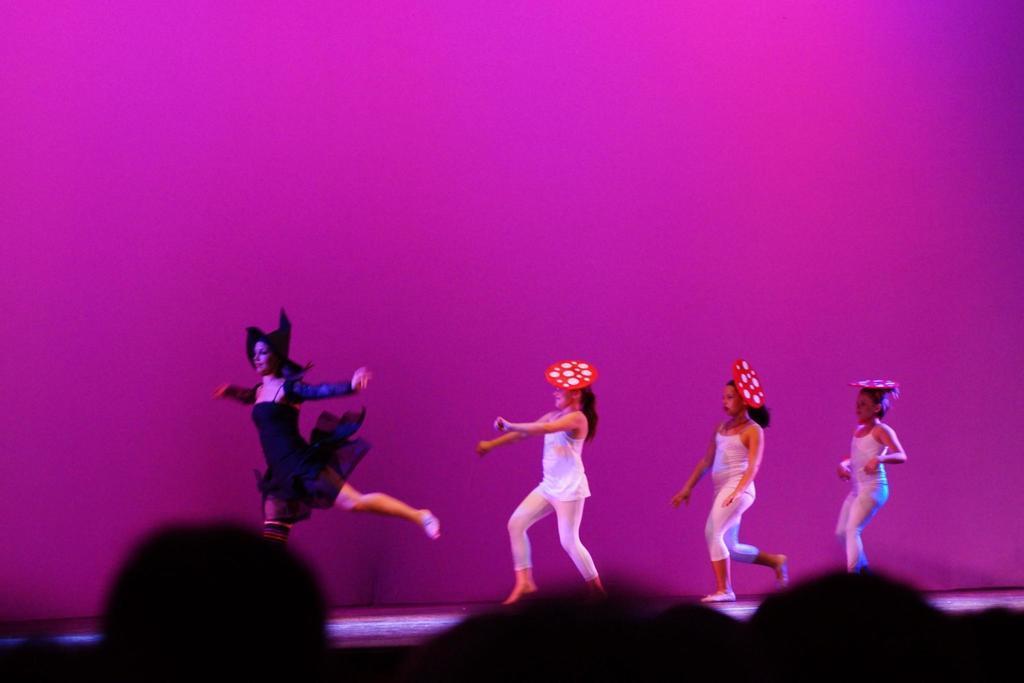Can you describe this image briefly? In this image we can see this person wearing a black dress and these people wearing white dresses are on the stage. The background of the image is in purple color. This part of the image is dark. 